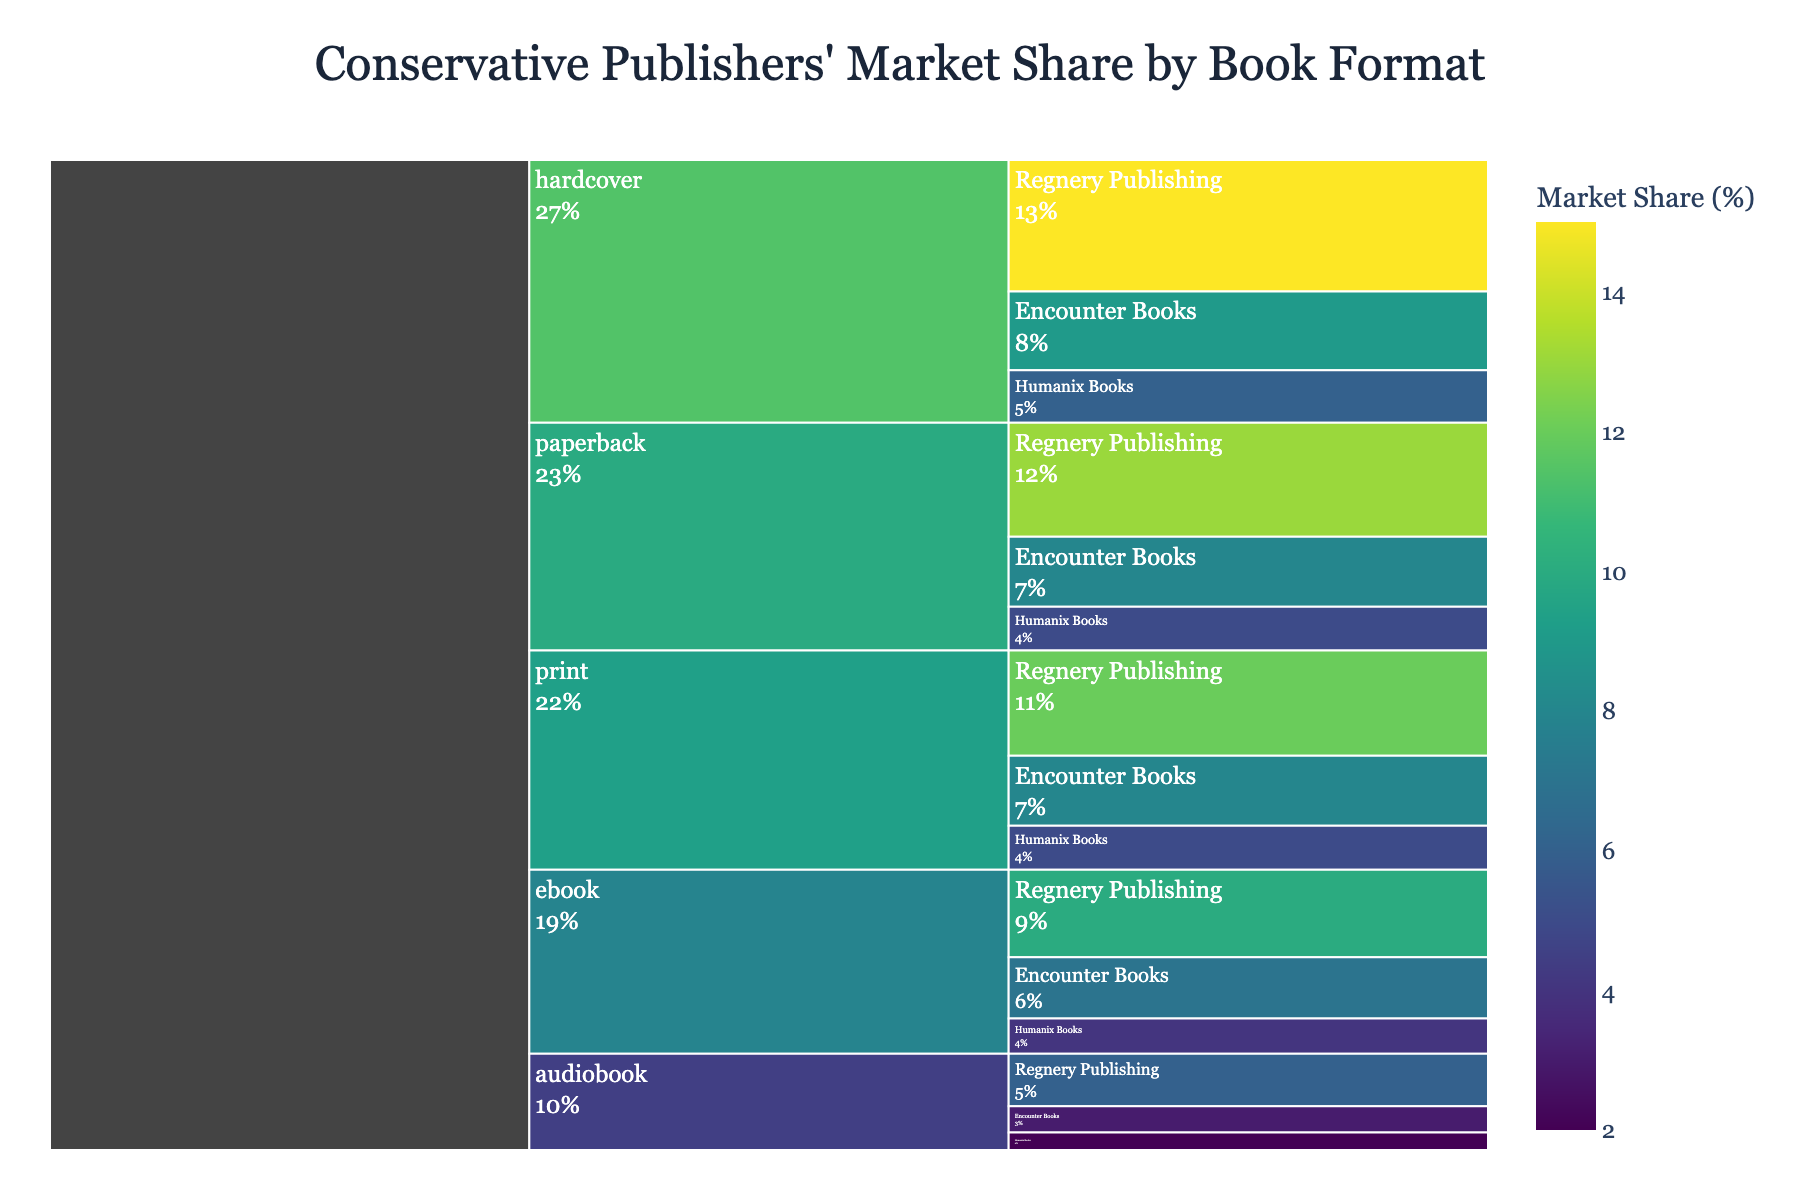How many different book formats are shown in the figure? The Icicle Chart presents different segments for each book format at the top level. These segments are clearly labeled and visually distinct. Counting these segments will tell us the number of different book formats.
Answer: 5 Which publisher has the highest market share in the print format? To answer this, identify the section of the Icicle Chart labeled 'print' and then within that section, find the publisher segment with the largest value.
Answer: Regnery Publishing What is the combined market share of Encounter Books across all formats? Find the segments corresponding to Encounter Books within each book format. Sum the market share values: 8 (print) + 7 (ebook) + 3 (audiobook) + 9 (hardcover) + 8 (paperback).
Answer: 35 Which book format has the lowest market share for Humanix Books? Locate the segments related to Humanix Books in each book format and compare their market share values: 5 (print), 4 (ebook), 2 (audiobook), 6 (hardcover), 5 (paperback).
Answer: Audiobook Compare the total market share of Regnery Publishing to Encounter Books. Which one is greater, and by how much? Calculate the total market share for each publisher by summing their shares across all formats:
- Regnery Publishing: 12 (print) + 10 (ebook) + 6 (audiobook) + 15 (hardcover) + 13 (paperback) = 56
- Encounter Books: 8 (print) + 7 (ebook) + 3 (audiobook) + 9 (hardcover) + 8 (paperback) = 35
Subtract Encounter's total from Regnery's to determine the difference.
Answer: Regnery Publishing by 21 What is the market share percentage difference between the print and ebook formats for Regnery Publishing? Identify the market share for Regnery Publishing in the print format (12) and in the ebook format (10). Calculate the difference (12 - 10).
Answer: 2 Which book format shows the largest total market share when combined for all publishers? Sum the market shares for all publishers within each format, then identify the format with the highest total:
- Print: 12 + 8 + 5 = 25
- Ebook: 10 + 7 + 4 = 21
- Audiobook: 6 + 3 + 2 = 11
- Hardcover: 15 + 9 + 6 = 30
- Paperback: 13 + 8 + 5 = 26
Hardcover has the largest total.
Answer: Hardcover What is the proportion of Encounter Books' market share in hardcover compared to its market share in print? Find the market shares for Encounter Books in hardcover (9) and print (8). Calculate the proportion as 9/8.
Answer: 9/8 or 1.125 In which book format does Humanix Books have exactly half the market share of Regnery Publishing? Compare Humanix Books' market share to Regnery Publishing's in each format to find the one where Humanix has half:
- Print: 5 vs. 12
- Ebook: 4 vs. 10
- Audiobook: 2 vs. 6 (half)
- Hardcover: 6 vs. 15
- Paperback: 5 vs. 13
Humanix Books has half in the audiobook format.
Answer: Audiobook 